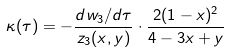<formula> <loc_0><loc_0><loc_500><loc_500>\kappa ( \tau ) = - \frac { d w _ { 3 } / d \tau } { z _ { 3 } ( x , y ) } \cdot \frac { 2 ( 1 - x ) ^ { 2 } } { 4 - 3 x + y }</formula> 